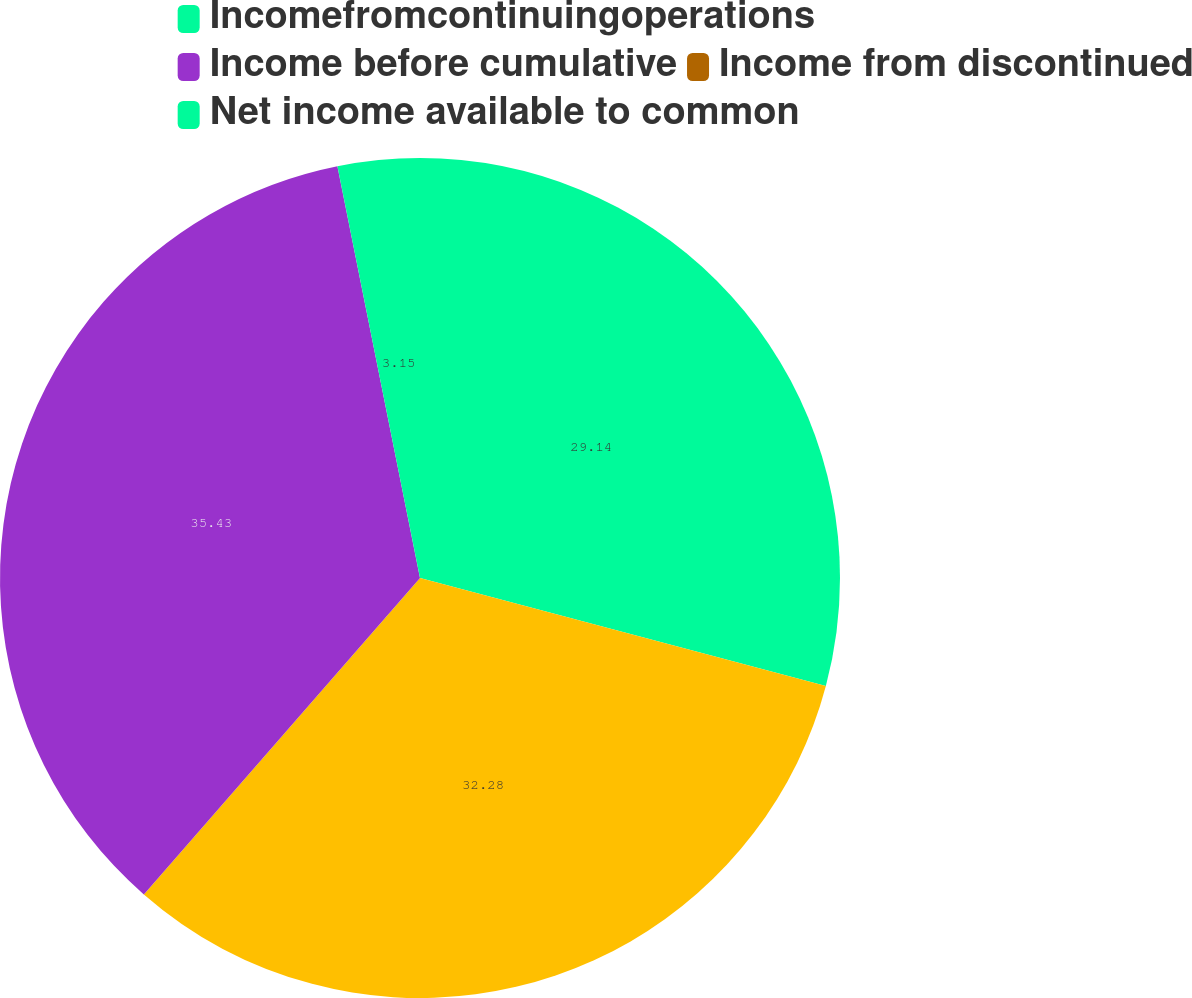<chart> <loc_0><loc_0><loc_500><loc_500><pie_chart><fcel>Incomefromcontinuingoperations<fcel>Unnamed: 1<fcel>Income before cumulative<fcel>Income from discontinued<fcel>Net income available to common<nl><fcel>29.14%<fcel>32.28%<fcel>35.43%<fcel>0.0%<fcel>3.15%<nl></chart> 